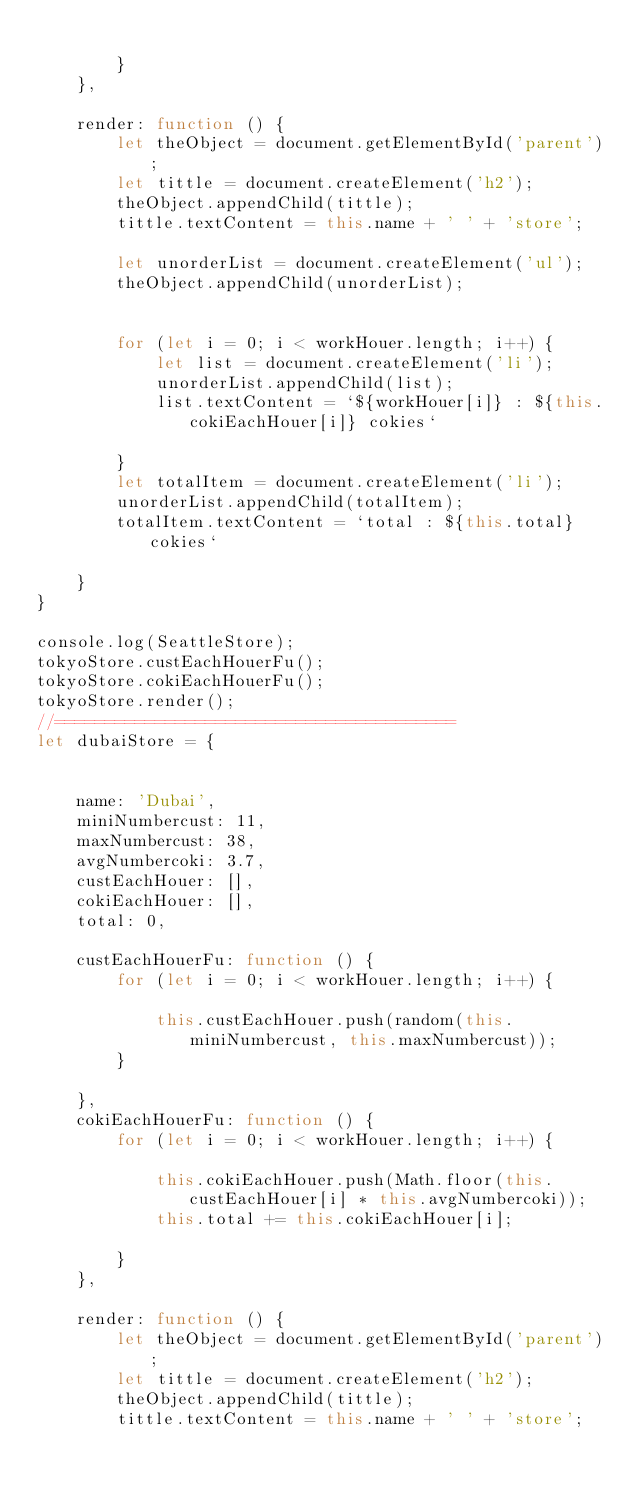Convert code to text. <code><loc_0><loc_0><loc_500><loc_500><_JavaScript_>            
        }
    },
    
    render: function () {
        let theObject = document.getElementById('parent');
        let tittle = document.createElement('h2');
        theObject.appendChild(tittle);
        tittle.textContent = this.name + ' ' + 'store';
        
        let unorderList = document.createElement('ul');
        theObject.appendChild(unorderList);
        
        
        for (let i = 0; i < workHouer.length; i++) {
            let list = document.createElement('li');
            unorderList.appendChild(list);
            list.textContent = `${workHouer[i]} : ${this.cokiEachHouer[i]} cokies`
            
        }
        let totalItem = document.createElement('li');
        unorderList.appendChild(totalItem);
        totalItem.textContent = `total : ${this.total} cokies`
        
    }
}

console.log(SeattleStore);
tokyoStore.custEachHouerFu();
tokyoStore.cokiEachHouerFu();
tokyoStore.render();
//========================================
let dubaiStore = {
    
    
    name: 'Dubai',
    miniNumbercust: 11,
    maxNumbercust: 38,
    avgNumbercoki: 3.7,
    custEachHouer: [],
    cokiEachHouer: [],
    total: 0,
    
    custEachHouerFu: function () {
        for (let i = 0; i < workHouer.length; i++) {
            
            this.custEachHouer.push(random(this.miniNumbercust, this.maxNumbercust));
        }
        
    },
    cokiEachHouerFu: function () {
        for (let i = 0; i < workHouer.length; i++) {
            
            this.cokiEachHouer.push(Math.floor(this.custEachHouer[i] * this.avgNumbercoki));
            this.total += this.cokiEachHouer[i];
            
        }
    },
    
    render: function () {
        let theObject = document.getElementById('parent');
        let tittle = document.createElement('h2');
        theObject.appendChild(tittle);
        tittle.textContent = this.name + ' ' + 'store';</code> 